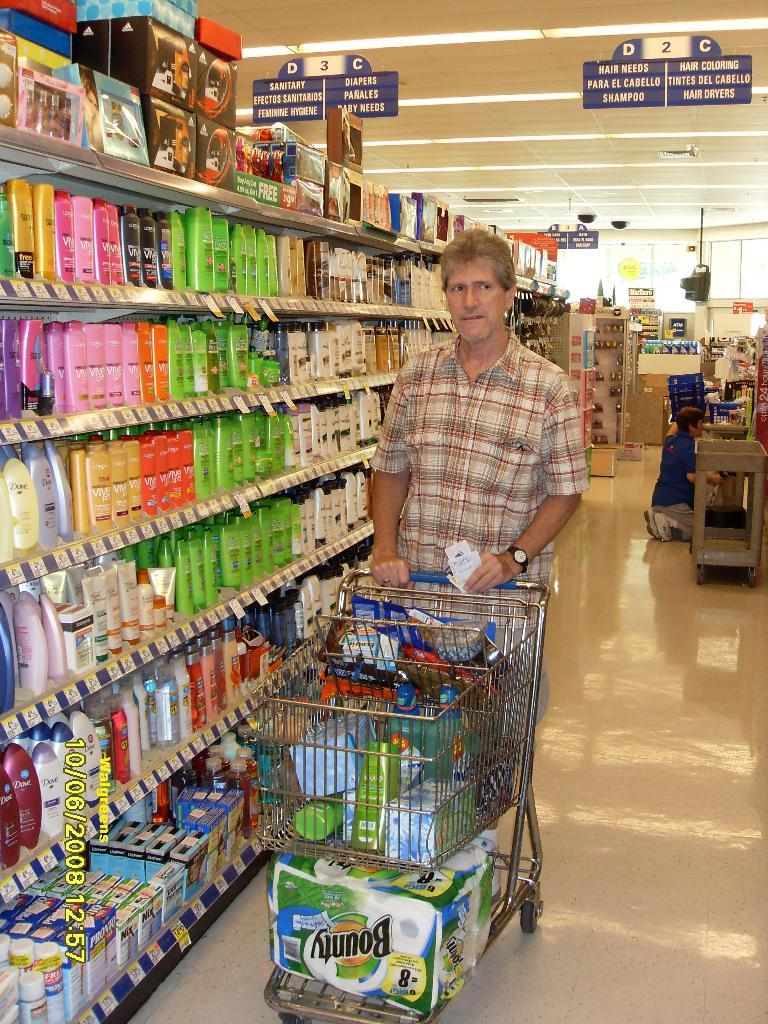Provide a one-sentence caption for the provided image. A man is walking with a cart full of stuff in the hair needs alley. 